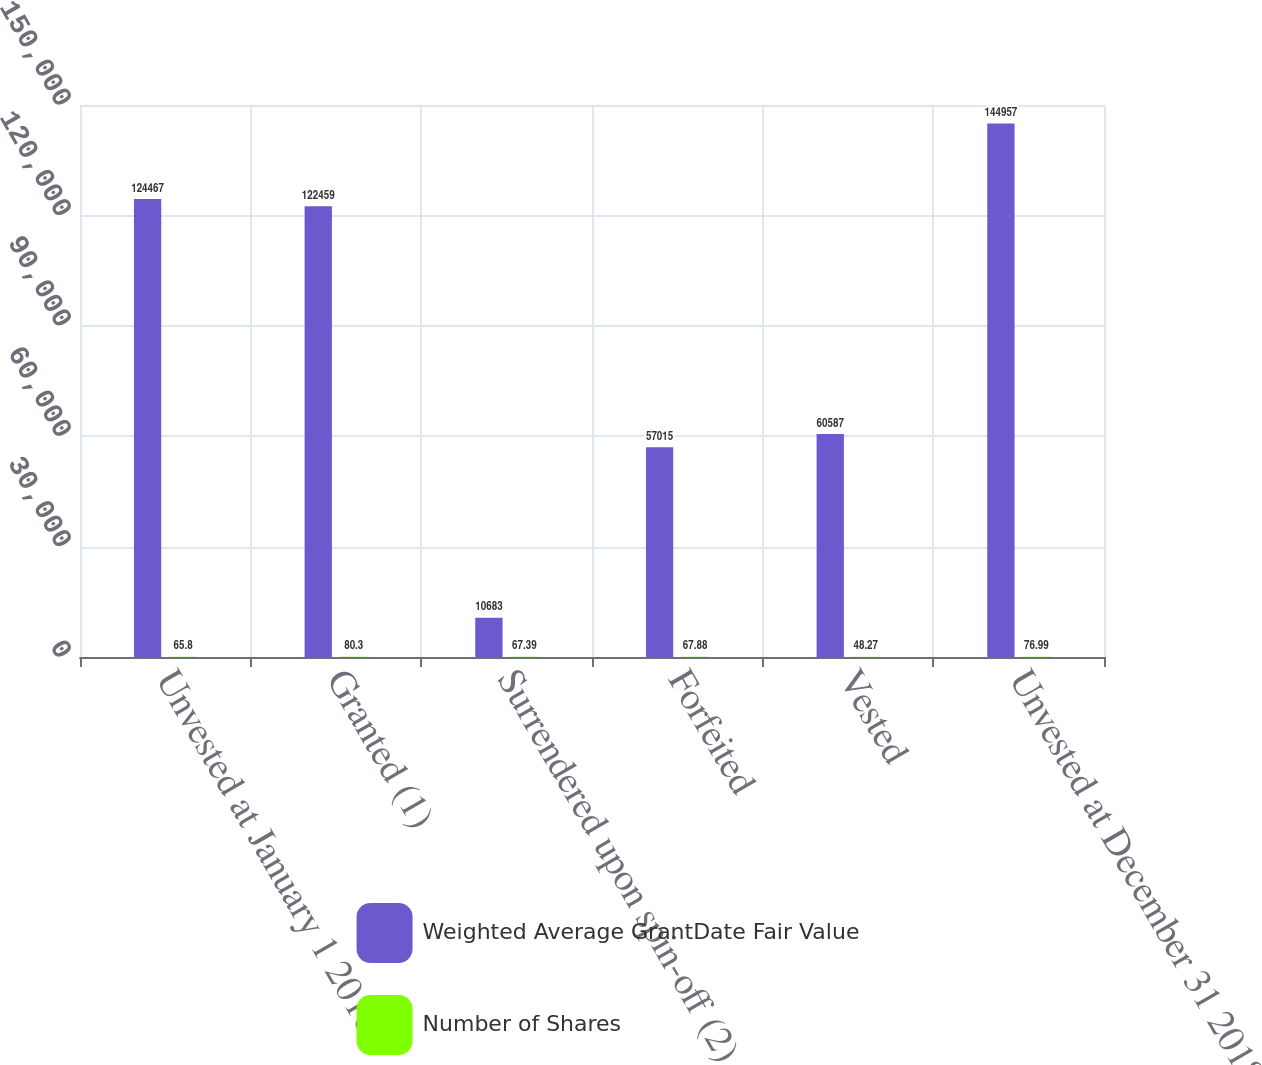Convert chart. <chart><loc_0><loc_0><loc_500><loc_500><stacked_bar_chart><ecel><fcel>Unvested at January 1 2018<fcel>Granted (1)<fcel>Surrendered upon spin-off (2)<fcel>Forfeited<fcel>Vested<fcel>Unvested at December 31 2018<nl><fcel>Weighted Average GrantDate Fair Value<fcel>124467<fcel>122459<fcel>10683<fcel>57015<fcel>60587<fcel>144957<nl><fcel>Number of Shares<fcel>65.8<fcel>80.3<fcel>67.39<fcel>67.88<fcel>48.27<fcel>76.99<nl></chart> 